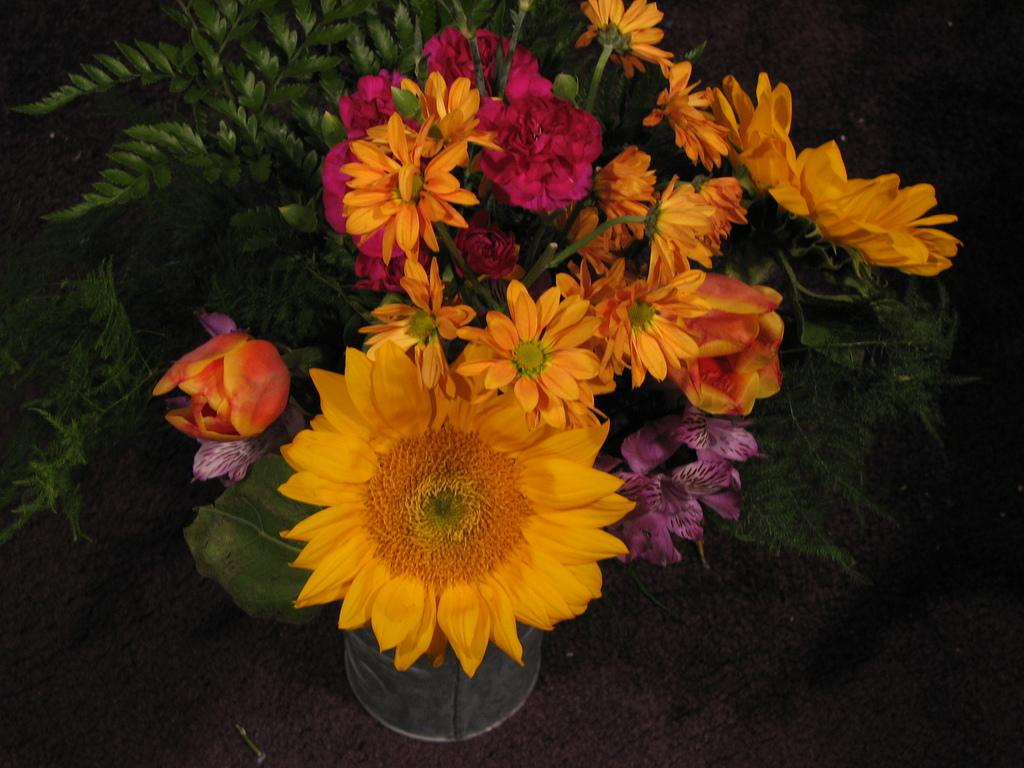What is the main subject in the center of the image? There are flower plants in the center of the image. What is located at the bottom of the image? There is a carpet at the bottom of the image. What type of wool is being used for the hair in the image? There is no wool or hair present in the image; it features flower plants and a carpet. 